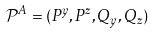<formula> <loc_0><loc_0><loc_500><loc_500>\mathcal { P } ^ { A } = ( P ^ { y } , P ^ { z } , Q _ { y } , Q _ { z } )</formula> 